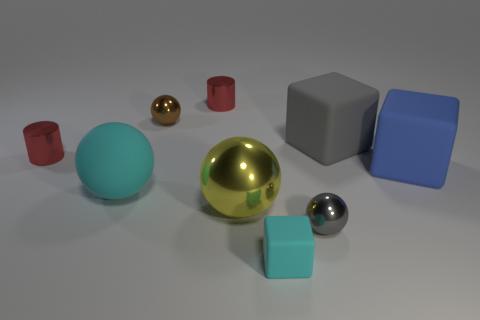What number of tiny things are the same shape as the large gray rubber thing?
Give a very brief answer. 1. Is the number of things left of the cyan rubber block the same as the number of tiny objects?
Ensure brevity in your answer.  Yes. The yellow metallic thing that is the same size as the cyan sphere is what shape?
Offer a terse response. Sphere. Is there a tiny brown metallic object of the same shape as the yellow metal object?
Offer a terse response. Yes. There is a cyan rubber object that is behind the small gray shiny thing that is on the right side of the tiny cyan rubber cube; is there a big thing that is right of it?
Provide a short and direct response. Yes. Are there more tiny cyan rubber objects to the left of the blue thing than red cylinders that are right of the large yellow shiny thing?
Your response must be concise. Yes. There is another sphere that is the same size as the gray ball; what is its material?
Your response must be concise. Metal. What number of large objects are either purple blocks or cyan matte objects?
Your answer should be compact. 1. Do the large gray matte object and the big cyan thing have the same shape?
Your answer should be very brief. No. How many tiny things are in front of the small brown metal object and behind the large cyan rubber sphere?
Give a very brief answer. 1. 